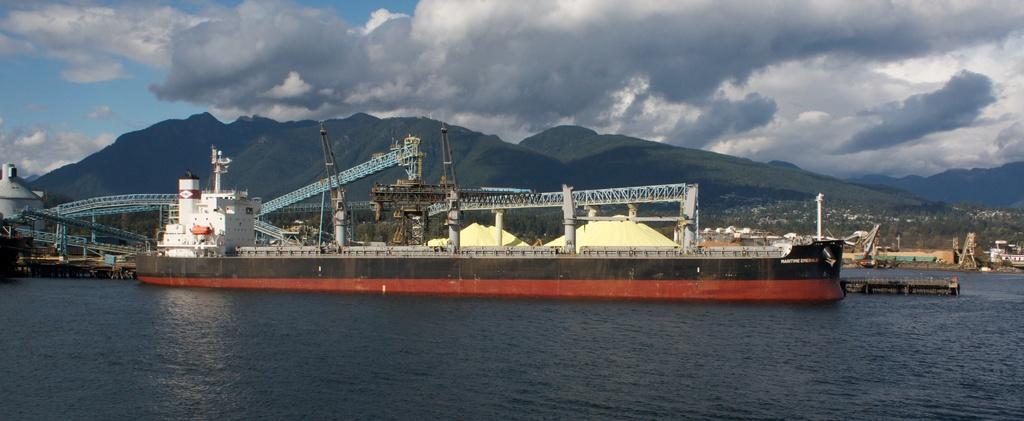What is the main subject of the image? The main subject of the image is a ship sailing on the water. What can be seen in the backdrop of the image? There are iron frames in the backdrop of the image. What other structures are visible in the image? There are buildings in the image. What type of natural landscape is present in the image? There are mountains with trees in the image. How would you describe the weather in the image? The sky is clear in the image, suggesting good weather. What type of creature is swimming alongside the ship in the image? There is no creature swimming alongside the ship in the image; it only shows the ship sailing on the water. 